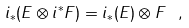Convert formula to latex. <formula><loc_0><loc_0><loc_500><loc_500>i _ { * } ( E \otimes i ^ { * } F ) = i _ { * } ( E ) \otimes F \ ,</formula> 